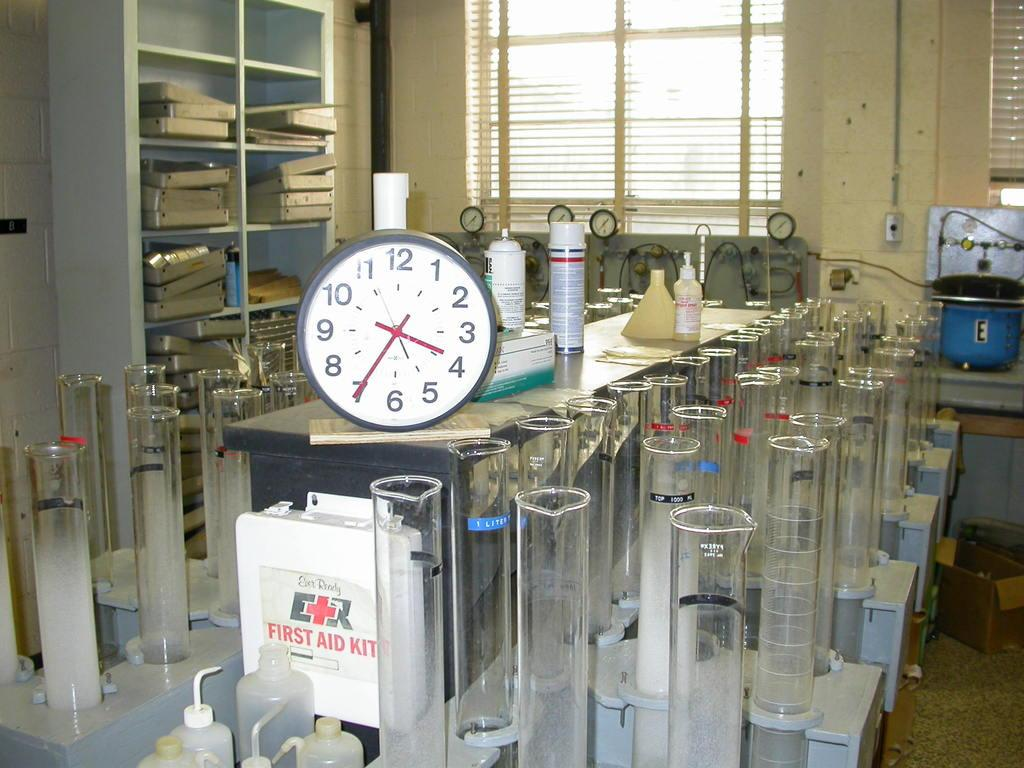<image>
Create a compact narrative representing the image presented. A clock is on a counter covered with medical measuring beakers directly over a First Aid kit. 